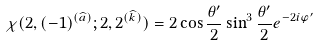Convert formula to latex. <formula><loc_0><loc_0><loc_500><loc_500>\chi ( 2 , ( - 1 ) ^ { ( \widehat { a } ) } ; 2 , 2 ^ { ( \widehat { k } ) } ) = 2 \cos \frac { \theta ^ { \prime } } 2 \sin ^ { 3 } \frac { \theta ^ { \prime } } 2 e ^ { - 2 i \varphi ^ { \prime } }</formula> 